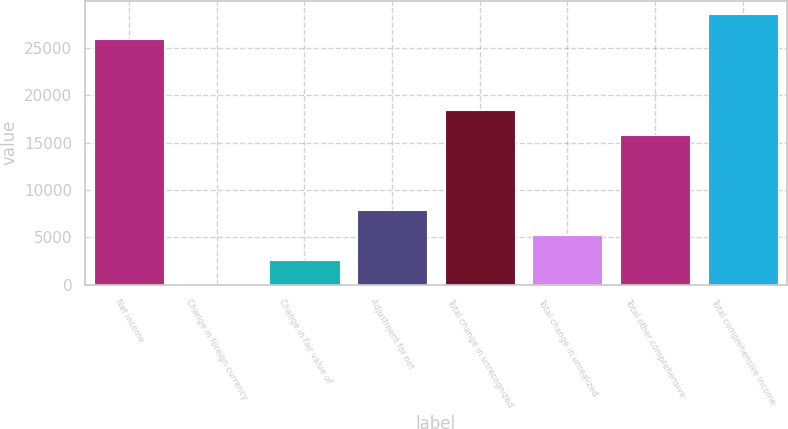Convert chart. <chart><loc_0><loc_0><loc_500><loc_500><bar_chart><fcel>Net income<fcel>Change in foreign currency<fcel>Change in fair value of<fcel>Adjustment for net<fcel>Total change in unrecognized<fcel>Total change in unrealized<fcel>Total other comprehensive<fcel>Total comprehensive income<nl><fcel>25922<fcel>12<fcel>2651.9<fcel>7931.7<fcel>18491.3<fcel>5291.8<fcel>15851.4<fcel>28561.9<nl></chart> 